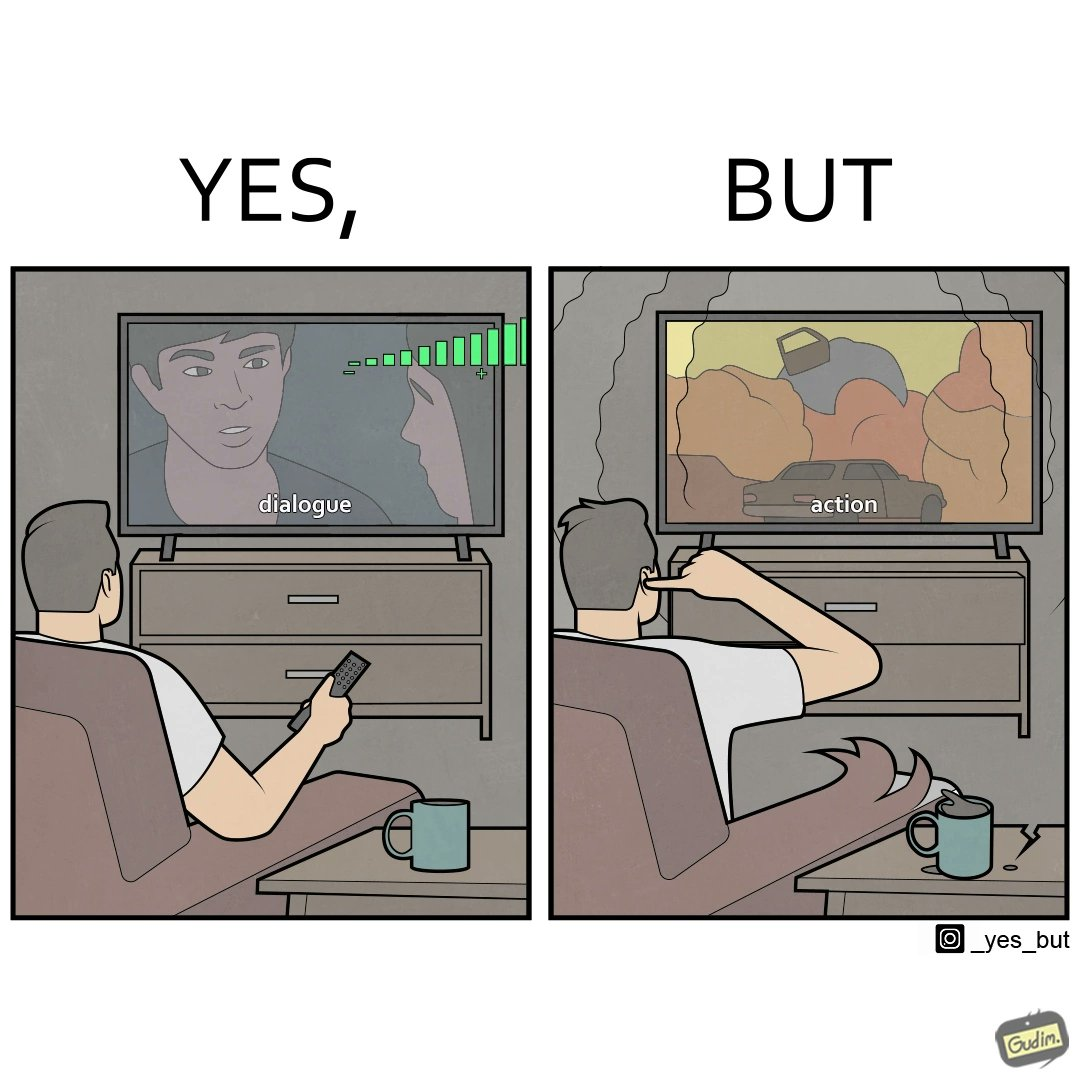Compare the left and right sides of this image. In the left part of the image: a person watching TV and increasing the volume of TV, maybe because he is not able to hear the dialogues properly In the right part of the image: a person covering his ears from the loud noise of TV, maybe because of the action scenes 